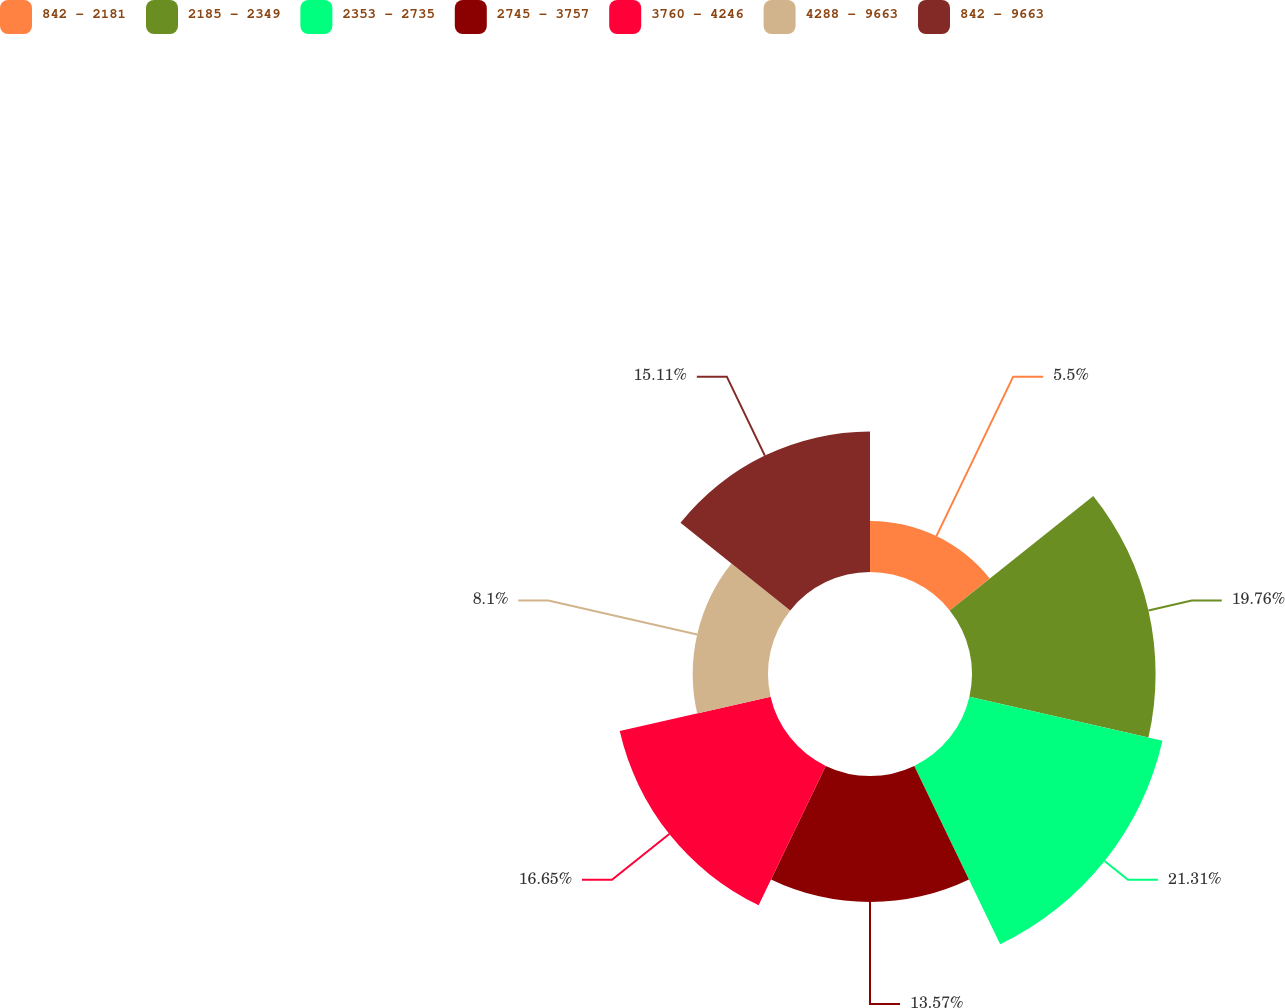<chart> <loc_0><loc_0><loc_500><loc_500><pie_chart><fcel>842 - 2181<fcel>2185 - 2349<fcel>2353 - 2735<fcel>2745 - 3757<fcel>3760 - 4246<fcel>4288 - 9663<fcel>842 - 9663<nl><fcel>5.5%<fcel>19.76%<fcel>21.31%<fcel>13.57%<fcel>16.65%<fcel>8.1%<fcel>15.11%<nl></chart> 